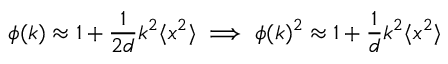Convert formula to latex. <formula><loc_0><loc_0><loc_500><loc_500>\phi ( k ) \approx 1 + \frac { 1 } { 2 d } k ^ { 2 } \langle x ^ { 2 } \rangle \implies \phi ( k ) ^ { 2 } \approx 1 + \frac { 1 } { d } k ^ { 2 } \langle x ^ { 2 } \rangle</formula> 